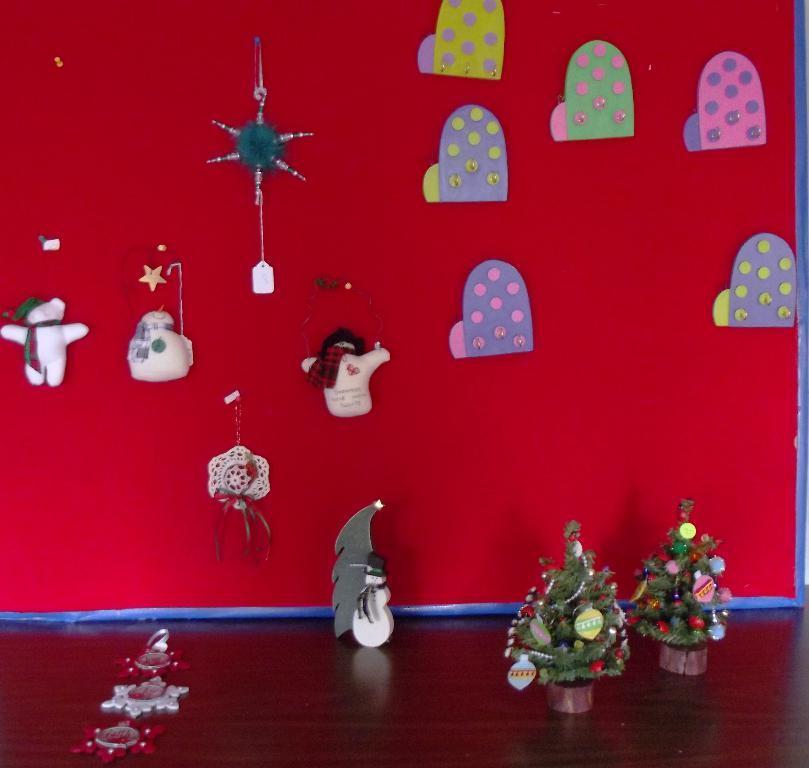In one or two sentences, can you explain what this image depicts? In this picture I can see there is a board here and there are some snowman keychains and many other placed here. There are Christmas trees placed here on the table. 